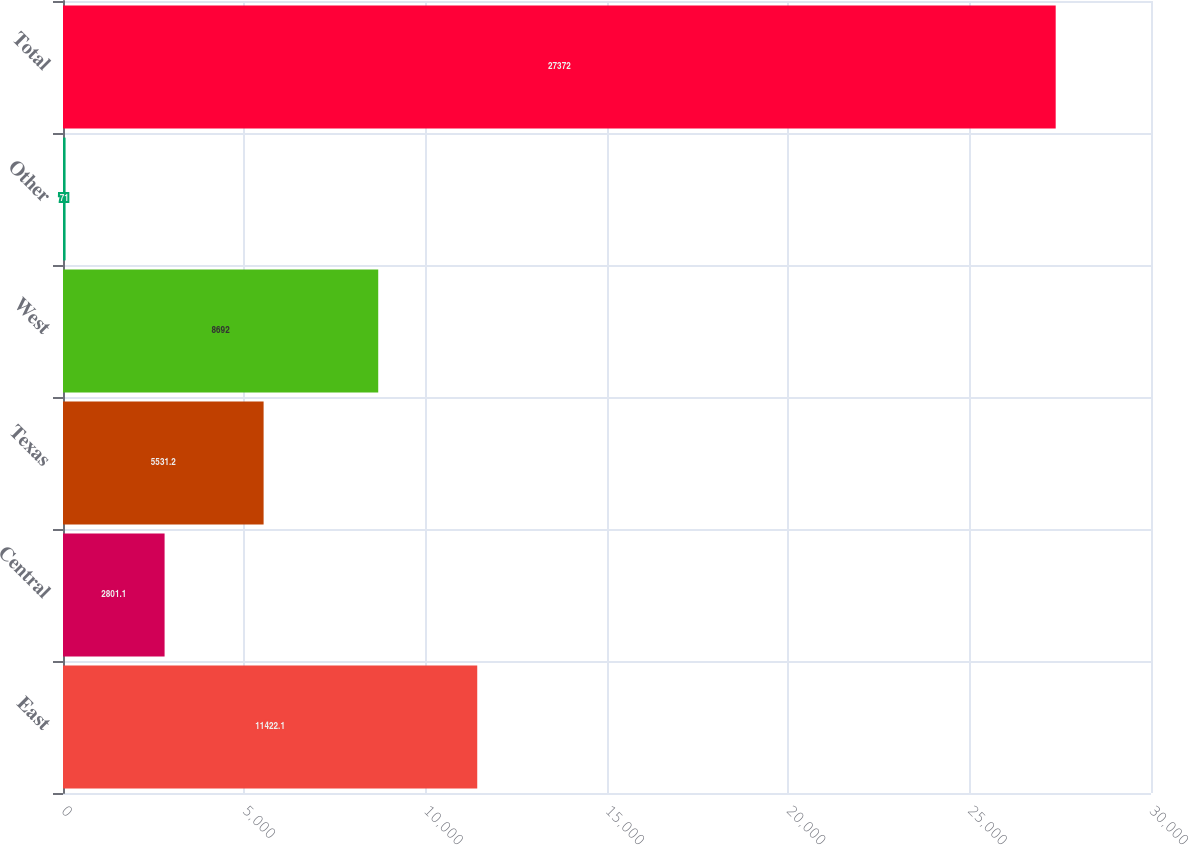<chart> <loc_0><loc_0><loc_500><loc_500><bar_chart><fcel>East<fcel>Central<fcel>Texas<fcel>West<fcel>Other<fcel>Total<nl><fcel>11422.1<fcel>2801.1<fcel>5531.2<fcel>8692<fcel>71<fcel>27372<nl></chart> 